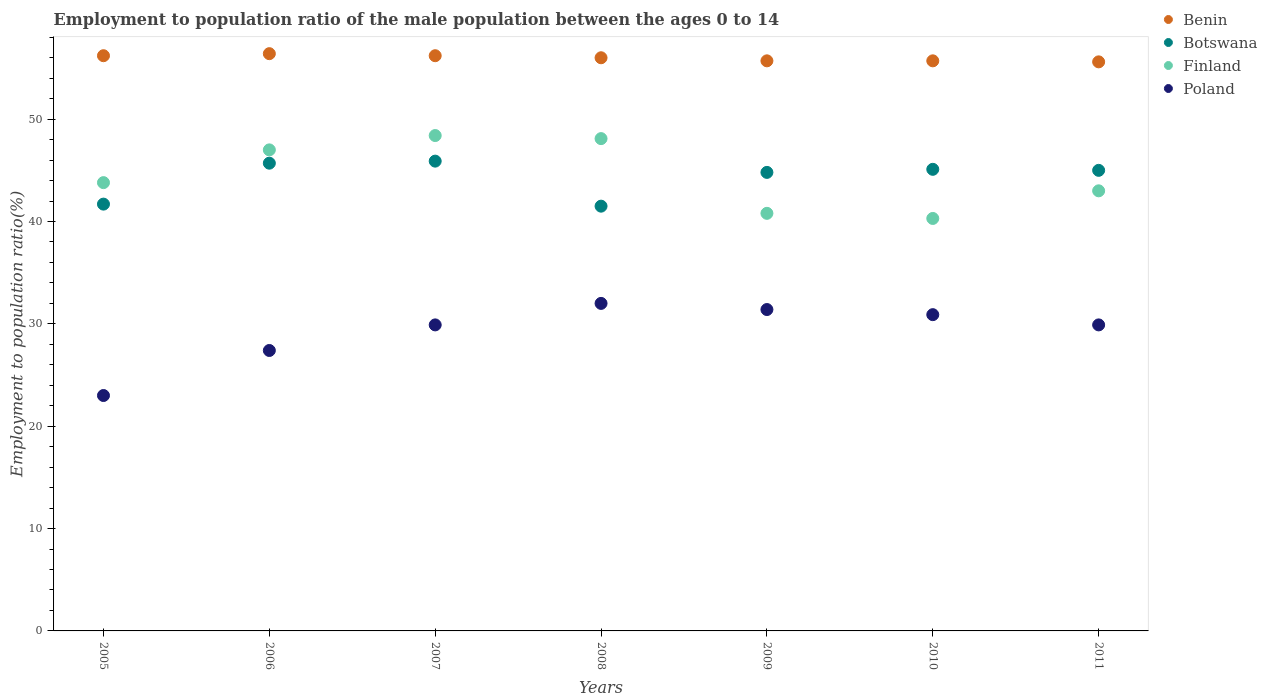How many different coloured dotlines are there?
Keep it short and to the point. 4. Is the number of dotlines equal to the number of legend labels?
Ensure brevity in your answer.  Yes. What is the employment to population ratio in Benin in 2010?
Your response must be concise. 55.7. Across all years, what is the maximum employment to population ratio in Botswana?
Offer a very short reply. 45.9. Across all years, what is the minimum employment to population ratio in Benin?
Provide a short and direct response. 55.6. In which year was the employment to population ratio in Poland minimum?
Your answer should be compact. 2005. What is the total employment to population ratio in Poland in the graph?
Your answer should be very brief. 204.5. What is the difference between the employment to population ratio in Benin in 2009 and that in 2011?
Your answer should be very brief. 0.1. What is the difference between the employment to population ratio in Finland in 2011 and the employment to population ratio in Poland in 2007?
Your answer should be very brief. 13.1. What is the average employment to population ratio in Benin per year?
Offer a terse response. 55.97. In the year 2007, what is the difference between the employment to population ratio in Finland and employment to population ratio in Benin?
Provide a short and direct response. -7.8. What is the ratio of the employment to population ratio in Finland in 2005 to that in 2010?
Provide a short and direct response. 1.09. What is the difference between the highest and the second highest employment to population ratio in Poland?
Ensure brevity in your answer.  0.6. What is the difference between the highest and the lowest employment to population ratio in Botswana?
Give a very brief answer. 4.4. Is the sum of the employment to population ratio in Benin in 2006 and 2008 greater than the maximum employment to population ratio in Poland across all years?
Your answer should be very brief. Yes. Is it the case that in every year, the sum of the employment to population ratio in Benin and employment to population ratio in Botswana  is greater than the employment to population ratio in Poland?
Keep it short and to the point. Yes. Does the employment to population ratio in Poland monotonically increase over the years?
Your answer should be compact. No. How many dotlines are there?
Your response must be concise. 4. What is the difference between two consecutive major ticks on the Y-axis?
Offer a very short reply. 10. Does the graph contain grids?
Provide a succinct answer. No. What is the title of the graph?
Your answer should be very brief. Employment to population ratio of the male population between the ages 0 to 14. What is the Employment to population ratio(%) of Benin in 2005?
Your answer should be very brief. 56.2. What is the Employment to population ratio(%) in Botswana in 2005?
Your answer should be very brief. 41.7. What is the Employment to population ratio(%) in Finland in 2005?
Keep it short and to the point. 43.8. What is the Employment to population ratio(%) in Benin in 2006?
Provide a short and direct response. 56.4. What is the Employment to population ratio(%) in Botswana in 2006?
Your answer should be very brief. 45.7. What is the Employment to population ratio(%) in Poland in 2006?
Your answer should be compact. 27.4. What is the Employment to population ratio(%) in Benin in 2007?
Provide a succinct answer. 56.2. What is the Employment to population ratio(%) in Botswana in 2007?
Give a very brief answer. 45.9. What is the Employment to population ratio(%) in Finland in 2007?
Provide a succinct answer. 48.4. What is the Employment to population ratio(%) in Poland in 2007?
Your response must be concise. 29.9. What is the Employment to population ratio(%) of Benin in 2008?
Your answer should be compact. 56. What is the Employment to population ratio(%) of Botswana in 2008?
Your response must be concise. 41.5. What is the Employment to population ratio(%) of Finland in 2008?
Provide a succinct answer. 48.1. What is the Employment to population ratio(%) of Benin in 2009?
Provide a short and direct response. 55.7. What is the Employment to population ratio(%) in Botswana in 2009?
Offer a very short reply. 44.8. What is the Employment to population ratio(%) in Finland in 2009?
Offer a very short reply. 40.8. What is the Employment to population ratio(%) of Poland in 2009?
Your answer should be very brief. 31.4. What is the Employment to population ratio(%) of Benin in 2010?
Offer a very short reply. 55.7. What is the Employment to population ratio(%) in Botswana in 2010?
Provide a succinct answer. 45.1. What is the Employment to population ratio(%) in Finland in 2010?
Offer a terse response. 40.3. What is the Employment to population ratio(%) of Poland in 2010?
Provide a short and direct response. 30.9. What is the Employment to population ratio(%) of Benin in 2011?
Ensure brevity in your answer.  55.6. What is the Employment to population ratio(%) in Botswana in 2011?
Offer a very short reply. 45. What is the Employment to population ratio(%) in Poland in 2011?
Offer a very short reply. 29.9. Across all years, what is the maximum Employment to population ratio(%) in Benin?
Ensure brevity in your answer.  56.4. Across all years, what is the maximum Employment to population ratio(%) of Botswana?
Your response must be concise. 45.9. Across all years, what is the maximum Employment to population ratio(%) of Finland?
Offer a terse response. 48.4. Across all years, what is the minimum Employment to population ratio(%) in Benin?
Keep it short and to the point. 55.6. Across all years, what is the minimum Employment to population ratio(%) in Botswana?
Keep it short and to the point. 41.5. Across all years, what is the minimum Employment to population ratio(%) in Finland?
Your answer should be very brief. 40.3. What is the total Employment to population ratio(%) in Benin in the graph?
Offer a terse response. 391.8. What is the total Employment to population ratio(%) of Botswana in the graph?
Your answer should be compact. 309.7. What is the total Employment to population ratio(%) of Finland in the graph?
Ensure brevity in your answer.  311.4. What is the total Employment to population ratio(%) of Poland in the graph?
Your answer should be very brief. 204.5. What is the difference between the Employment to population ratio(%) in Benin in 2005 and that in 2006?
Ensure brevity in your answer.  -0.2. What is the difference between the Employment to population ratio(%) in Botswana in 2005 and that in 2006?
Keep it short and to the point. -4. What is the difference between the Employment to population ratio(%) of Finland in 2005 and that in 2006?
Make the answer very short. -3.2. What is the difference between the Employment to population ratio(%) in Finland in 2005 and that in 2007?
Ensure brevity in your answer.  -4.6. What is the difference between the Employment to population ratio(%) of Poland in 2005 and that in 2007?
Make the answer very short. -6.9. What is the difference between the Employment to population ratio(%) of Benin in 2005 and that in 2008?
Offer a very short reply. 0.2. What is the difference between the Employment to population ratio(%) in Finland in 2005 and that in 2008?
Offer a very short reply. -4.3. What is the difference between the Employment to population ratio(%) in Poland in 2005 and that in 2008?
Offer a terse response. -9. What is the difference between the Employment to population ratio(%) of Finland in 2005 and that in 2009?
Make the answer very short. 3. What is the difference between the Employment to population ratio(%) in Benin in 2005 and that in 2010?
Your answer should be very brief. 0.5. What is the difference between the Employment to population ratio(%) of Finland in 2005 and that in 2010?
Provide a succinct answer. 3.5. What is the difference between the Employment to population ratio(%) in Poland in 2005 and that in 2010?
Offer a very short reply. -7.9. What is the difference between the Employment to population ratio(%) in Finland in 2005 and that in 2011?
Give a very brief answer. 0.8. What is the difference between the Employment to population ratio(%) in Poland in 2005 and that in 2011?
Your answer should be very brief. -6.9. What is the difference between the Employment to population ratio(%) of Benin in 2006 and that in 2007?
Give a very brief answer. 0.2. What is the difference between the Employment to population ratio(%) of Botswana in 2006 and that in 2007?
Keep it short and to the point. -0.2. What is the difference between the Employment to population ratio(%) in Benin in 2006 and that in 2008?
Make the answer very short. 0.4. What is the difference between the Employment to population ratio(%) of Poland in 2006 and that in 2008?
Offer a very short reply. -4.6. What is the difference between the Employment to population ratio(%) in Benin in 2006 and that in 2009?
Keep it short and to the point. 0.7. What is the difference between the Employment to population ratio(%) of Botswana in 2006 and that in 2010?
Offer a very short reply. 0.6. What is the difference between the Employment to population ratio(%) in Finland in 2006 and that in 2010?
Your answer should be very brief. 6.7. What is the difference between the Employment to population ratio(%) in Poland in 2006 and that in 2010?
Give a very brief answer. -3.5. What is the difference between the Employment to population ratio(%) in Benin in 2006 and that in 2011?
Ensure brevity in your answer.  0.8. What is the difference between the Employment to population ratio(%) of Poland in 2006 and that in 2011?
Offer a very short reply. -2.5. What is the difference between the Employment to population ratio(%) in Benin in 2007 and that in 2008?
Ensure brevity in your answer.  0.2. What is the difference between the Employment to population ratio(%) of Botswana in 2007 and that in 2008?
Provide a succinct answer. 4.4. What is the difference between the Employment to population ratio(%) of Finland in 2007 and that in 2008?
Provide a short and direct response. 0.3. What is the difference between the Employment to population ratio(%) in Finland in 2007 and that in 2009?
Your answer should be compact. 7.6. What is the difference between the Employment to population ratio(%) in Poland in 2007 and that in 2009?
Provide a short and direct response. -1.5. What is the difference between the Employment to population ratio(%) of Benin in 2007 and that in 2010?
Ensure brevity in your answer.  0.5. What is the difference between the Employment to population ratio(%) in Finland in 2007 and that in 2010?
Ensure brevity in your answer.  8.1. What is the difference between the Employment to population ratio(%) in Botswana in 2007 and that in 2011?
Give a very brief answer. 0.9. What is the difference between the Employment to population ratio(%) of Poland in 2007 and that in 2011?
Your response must be concise. 0. What is the difference between the Employment to population ratio(%) in Finland in 2008 and that in 2009?
Your answer should be compact. 7.3. What is the difference between the Employment to population ratio(%) of Poland in 2008 and that in 2009?
Your response must be concise. 0.6. What is the difference between the Employment to population ratio(%) of Finland in 2008 and that in 2010?
Give a very brief answer. 7.8. What is the difference between the Employment to population ratio(%) in Poland in 2008 and that in 2011?
Your answer should be very brief. 2.1. What is the difference between the Employment to population ratio(%) of Benin in 2009 and that in 2010?
Keep it short and to the point. 0. What is the difference between the Employment to population ratio(%) of Botswana in 2009 and that in 2010?
Ensure brevity in your answer.  -0.3. What is the difference between the Employment to population ratio(%) in Poland in 2009 and that in 2010?
Offer a terse response. 0.5. What is the difference between the Employment to population ratio(%) of Benin in 2009 and that in 2011?
Offer a very short reply. 0.1. What is the difference between the Employment to population ratio(%) in Botswana in 2009 and that in 2011?
Your answer should be very brief. -0.2. What is the difference between the Employment to population ratio(%) in Poland in 2009 and that in 2011?
Keep it short and to the point. 1.5. What is the difference between the Employment to population ratio(%) in Benin in 2010 and that in 2011?
Your response must be concise. 0.1. What is the difference between the Employment to population ratio(%) in Botswana in 2010 and that in 2011?
Provide a succinct answer. 0.1. What is the difference between the Employment to population ratio(%) of Benin in 2005 and the Employment to population ratio(%) of Poland in 2006?
Your answer should be very brief. 28.8. What is the difference between the Employment to population ratio(%) of Benin in 2005 and the Employment to population ratio(%) of Poland in 2007?
Provide a succinct answer. 26.3. What is the difference between the Employment to population ratio(%) of Botswana in 2005 and the Employment to population ratio(%) of Finland in 2007?
Your answer should be very brief. -6.7. What is the difference between the Employment to population ratio(%) of Botswana in 2005 and the Employment to population ratio(%) of Poland in 2007?
Provide a succinct answer. 11.8. What is the difference between the Employment to population ratio(%) of Finland in 2005 and the Employment to population ratio(%) of Poland in 2007?
Make the answer very short. 13.9. What is the difference between the Employment to population ratio(%) of Benin in 2005 and the Employment to population ratio(%) of Botswana in 2008?
Offer a very short reply. 14.7. What is the difference between the Employment to population ratio(%) in Benin in 2005 and the Employment to population ratio(%) in Poland in 2008?
Provide a succinct answer. 24.2. What is the difference between the Employment to population ratio(%) of Botswana in 2005 and the Employment to population ratio(%) of Finland in 2008?
Provide a succinct answer. -6.4. What is the difference between the Employment to population ratio(%) of Benin in 2005 and the Employment to population ratio(%) of Botswana in 2009?
Make the answer very short. 11.4. What is the difference between the Employment to population ratio(%) in Benin in 2005 and the Employment to population ratio(%) in Poland in 2009?
Keep it short and to the point. 24.8. What is the difference between the Employment to population ratio(%) in Benin in 2005 and the Employment to population ratio(%) in Poland in 2010?
Your answer should be very brief. 25.3. What is the difference between the Employment to population ratio(%) of Botswana in 2005 and the Employment to population ratio(%) of Poland in 2010?
Your answer should be compact. 10.8. What is the difference between the Employment to population ratio(%) of Finland in 2005 and the Employment to population ratio(%) of Poland in 2010?
Provide a succinct answer. 12.9. What is the difference between the Employment to population ratio(%) in Benin in 2005 and the Employment to population ratio(%) in Botswana in 2011?
Give a very brief answer. 11.2. What is the difference between the Employment to population ratio(%) in Benin in 2005 and the Employment to population ratio(%) in Finland in 2011?
Make the answer very short. 13.2. What is the difference between the Employment to population ratio(%) in Benin in 2005 and the Employment to population ratio(%) in Poland in 2011?
Provide a succinct answer. 26.3. What is the difference between the Employment to population ratio(%) of Finland in 2005 and the Employment to population ratio(%) of Poland in 2011?
Give a very brief answer. 13.9. What is the difference between the Employment to population ratio(%) in Benin in 2006 and the Employment to population ratio(%) in Botswana in 2007?
Give a very brief answer. 10.5. What is the difference between the Employment to population ratio(%) in Benin in 2006 and the Employment to population ratio(%) in Finland in 2007?
Offer a terse response. 8. What is the difference between the Employment to population ratio(%) of Benin in 2006 and the Employment to population ratio(%) of Poland in 2007?
Make the answer very short. 26.5. What is the difference between the Employment to population ratio(%) of Botswana in 2006 and the Employment to population ratio(%) of Finland in 2007?
Provide a succinct answer. -2.7. What is the difference between the Employment to population ratio(%) in Benin in 2006 and the Employment to population ratio(%) in Finland in 2008?
Keep it short and to the point. 8.3. What is the difference between the Employment to population ratio(%) of Benin in 2006 and the Employment to population ratio(%) of Poland in 2008?
Give a very brief answer. 24.4. What is the difference between the Employment to population ratio(%) in Botswana in 2006 and the Employment to population ratio(%) in Finland in 2008?
Give a very brief answer. -2.4. What is the difference between the Employment to population ratio(%) of Botswana in 2006 and the Employment to population ratio(%) of Poland in 2008?
Make the answer very short. 13.7. What is the difference between the Employment to population ratio(%) in Finland in 2006 and the Employment to population ratio(%) in Poland in 2008?
Offer a very short reply. 15. What is the difference between the Employment to population ratio(%) of Benin in 2006 and the Employment to population ratio(%) of Poland in 2009?
Your answer should be compact. 25. What is the difference between the Employment to population ratio(%) of Botswana in 2006 and the Employment to population ratio(%) of Finland in 2009?
Provide a succinct answer. 4.9. What is the difference between the Employment to population ratio(%) of Botswana in 2006 and the Employment to population ratio(%) of Finland in 2010?
Provide a short and direct response. 5.4. What is the difference between the Employment to population ratio(%) in Botswana in 2006 and the Employment to population ratio(%) in Poland in 2010?
Your response must be concise. 14.8. What is the difference between the Employment to population ratio(%) of Benin in 2006 and the Employment to population ratio(%) of Botswana in 2011?
Ensure brevity in your answer.  11.4. What is the difference between the Employment to population ratio(%) of Benin in 2006 and the Employment to population ratio(%) of Poland in 2011?
Offer a terse response. 26.5. What is the difference between the Employment to population ratio(%) of Botswana in 2006 and the Employment to population ratio(%) of Finland in 2011?
Your answer should be very brief. 2.7. What is the difference between the Employment to population ratio(%) of Finland in 2006 and the Employment to population ratio(%) of Poland in 2011?
Your answer should be compact. 17.1. What is the difference between the Employment to population ratio(%) in Benin in 2007 and the Employment to population ratio(%) in Botswana in 2008?
Offer a terse response. 14.7. What is the difference between the Employment to population ratio(%) in Benin in 2007 and the Employment to population ratio(%) in Finland in 2008?
Your answer should be compact. 8.1. What is the difference between the Employment to population ratio(%) in Benin in 2007 and the Employment to population ratio(%) in Poland in 2008?
Keep it short and to the point. 24.2. What is the difference between the Employment to population ratio(%) in Botswana in 2007 and the Employment to population ratio(%) in Finland in 2008?
Make the answer very short. -2.2. What is the difference between the Employment to population ratio(%) of Benin in 2007 and the Employment to population ratio(%) of Botswana in 2009?
Offer a terse response. 11.4. What is the difference between the Employment to population ratio(%) of Benin in 2007 and the Employment to population ratio(%) of Finland in 2009?
Give a very brief answer. 15.4. What is the difference between the Employment to population ratio(%) in Benin in 2007 and the Employment to population ratio(%) in Poland in 2009?
Ensure brevity in your answer.  24.8. What is the difference between the Employment to population ratio(%) of Botswana in 2007 and the Employment to population ratio(%) of Poland in 2009?
Your answer should be compact. 14.5. What is the difference between the Employment to population ratio(%) of Finland in 2007 and the Employment to population ratio(%) of Poland in 2009?
Ensure brevity in your answer.  17. What is the difference between the Employment to population ratio(%) of Benin in 2007 and the Employment to population ratio(%) of Botswana in 2010?
Give a very brief answer. 11.1. What is the difference between the Employment to population ratio(%) of Benin in 2007 and the Employment to population ratio(%) of Finland in 2010?
Give a very brief answer. 15.9. What is the difference between the Employment to population ratio(%) of Benin in 2007 and the Employment to population ratio(%) of Poland in 2010?
Make the answer very short. 25.3. What is the difference between the Employment to population ratio(%) of Botswana in 2007 and the Employment to population ratio(%) of Finland in 2010?
Offer a very short reply. 5.6. What is the difference between the Employment to population ratio(%) of Botswana in 2007 and the Employment to population ratio(%) of Poland in 2010?
Give a very brief answer. 15. What is the difference between the Employment to population ratio(%) of Benin in 2007 and the Employment to population ratio(%) of Botswana in 2011?
Your answer should be compact. 11.2. What is the difference between the Employment to population ratio(%) in Benin in 2007 and the Employment to population ratio(%) in Finland in 2011?
Give a very brief answer. 13.2. What is the difference between the Employment to population ratio(%) in Benin in 2007 and the Employment to population ratio(%) in Poland in 2011?
Offer a terse response. 26.3. What is the difference between the Employment to population ratio(%) in Botswana in 2007 and the Employment to population ratio(%) in Finland in 2011?
Keep it short and to the point. 2.9. What is the difference between the Employment to population ratio(%) of Benin in 2008 and the Employment to population ratio(%) of Botswana in 2009?
Your answer should be very brief. 11.2. What is the difference between the Employment to population ratio(%) of Benin in 2008 and the Employment to population ratio(%) of Finland in 2009?
Ensure brevity in your answer.  15.2. What is the difference between the Employment to population ratio(%) in Benin in 2008 and the Employment to population ratio(%) in Poland in 2009?
Your answer should be compact. 24.6. What is the difference between the Employment to population ratio(%) of Botswana in 2008 and the Employment to population ratio(%) of Finland in 2009?
Offer a very short reply. 0.7. What is the difference between the Employment to population ratio(%) in Benin in 2008 and the Employment to population ratio(%) in Poland in 2010?
Your answer should be compact. 25.1. What is the difference between the Employment to population ratio(%) of Botswana in 2008 and the Employment to population ratio(%) of Finland in 2010?
Offer a terse response. 1.2. What is the difference between the Employment to population ratio(%) in Finland in 2008 and the Employment to population ratio(%) in Poland in 2010?
Make the answer very short. 17.2. What is the difference between the Employment to population ratio(%) of Benin in 2008 and the Employment to population ratio(%) of Botswana in 2011?
Ensure brevity in your answer.  11. What is the difference between the Employment to population ratio(%) of Benin in 2008 and the Employment to population ratio(%) of Finland in 2011?
Keep it short and to the point. 13. What is the difference between the Employment to population ratio(%) of Benin in 2008 and the Employment to population ratio(%) of Poland in 2011?
Keep it short and to the point. 26.1. What is the difference between the Employment to population ratio(%) of Botswana in 2008 and the Employment to population ratio(%) of Finland in 2011?
Keep it short and to the point. -1.5. What is the difference between the Employment to population ratio(%) in Benin in 2009 and the Employment to population ratio(%) in Botswana in 2010?
Your response must be concise. 10.6. What is the difference between the Employment to population ratio(%) of Benin in 2009 and the Employment to population ratio(%) of Finland in 2010?
Offer a very short reply. 15.4. What is the difference between the Employment to population ratio(%) in Benin in 2009 and the Employment to population ratio(%) in Poland in 2010?
Make the answer very short. 24.8. What is the difference between the Employment to population ratio(%) in Botswana in 2009 and the Employment to population ratio(%) in Finland in 2010?
Offer a terse response. 4.5. What is the difference between the Employment to population ratio(%) of Benin in 2009 and the Employment to population ratio(%) of Botswana in 2011?
Offer a very short reply. 10.7. What is the difference between the Employment to population ratio(%) of Benin in 2009 and the Employment to population ratio(%) of Poland in 2011?
Ensure brevity in your answer.  25.8. What is the difference between the Employment to population ratio(%) of Botswana in 2009 and the Employment to population ratio(%) of Poland in 2011?
Provide a short and direct response. 14.9. What is the difference between the Employment to population ratio(%) of Finland in 2009 and the Employment to population ratio(%) of Poland in 2011?
Keep it short and to the point. 10.9. What is the difference between the Employment to population ratio(%) of Benin in 2010 and the Employment to population ratio(%) of Botswana in 2011?
Keep it short and to the point. 10.7. What is the difference between the Employment to population ratio(%) of Benin in 2010 and the Employment to population ratio(%) of Poland in 2011?
Your answer should be very brief. 25.8. What is the difference between the Employment to population ratio(%) in Botswana in 2010 and the Employment to population ratio(%) in Poland in 2011?
Provide a succinct answer. 15.2. What is the average Employment to population ratio(%) in Benin per year?
Offer a very short reply. 55.97. What is the average Employment to population ratio(%) in Botswana per year?
Provide a succinct answer. 44.24. What is the average Employment to population ratio(%) of Finland per year?
Provide a short and direct response. 44.49. What is the average Employment to population ratio(%) in Poland per year?
Offer a terse response. 29.21. In the year 2005, what is the difference between the Employment to population ratio(%) in Benin and Employment to population ratio(%) in Finland?
Offer a very short reply. 12.4. In the year 2005, what is the difference between the Employment to population ratio(%) of Benin and Employment to population ratio(%) of Poland?
Keep it short and to the point. 33.2. In the year 2005, what is the difference between the Employment to population ratio(%) of Finland and Employment to population ratio(%) of Poland?
Your response must be concise. 20.8. In the year 2006, what is the difference between the Employment to population ratio(%) in Benin and Employment to population ratio(%) in Botswana?
Your answer should be compact. 10.7. In the year 2006, what is the difference between the Employment to population ratio(%) of Benin and Employment to population ratio(%) of Finland?
Your response must be concise. 9.4. In the year 2006, what is the difference between the Employment to population ratio(%) of Botswana and Employment to population ratio(%) of Poland?
Provide a short and direct response. 18.3. In the year 2006, what is the difference between the Employment to population ratio(%) in Finland and Employment to population ratio(%) in Poland?
Make the answer very short. 19.6. In the year 2007, what is the difference between the Employment to population ratio(%) of Benin and Employment to population ratio(%) of Finland?
Give a very brief answer. 7.8. In the year 2007, what is the difference between the Employment to population ratio(%) in Benin and Employment to population ratio(%) in Poland?
Provide a succinct answer. 26.3. In the year 2007, what is the difference between the Employment to population ratio(%) of Botswana and Employment to population ratio(%) of Finland?
Ensure brevity in your answer.  -2.5. In the year 2007, what is the difference between the Employment to population ratio(%) of Botswana and Employment to population ratio(%) of Poland?
Provide a short and direct response. 16. In the year 2007, what is the difference between the Employment to population ratio(%) of Finland and Employment to population ratio(%) of Poland?
Give a very brief answer. 18.5. In the year 2008, what is the difference between the Employment to population ratio(%) in Benin and Employment to population ratio(%) in Finland?
Provide a short and direct response. 7.9. In the year 2008, what is the difference between the Employment to population ratio(%) of Botswana and Employment to population ratio(%) of Finland?
Keep it short and to the point. -6.6. In the year 2008, what is the difference between the Employment to population ratio(%) of Botswana and Employment to population ratio(%) of Poland?
Provide a short and direct response. 9.5. In the year 2009, what is the difference between the Employment to population ratio(%) in Benin and Employment to population ratio(%) in Botswana?
Offer a very short reply. 10.9. In the year 2009, what is the difference between the Employment to population ratio(%) in Benin and Employment to population ratio(%) in Poland?
Offer a terse response. 24.3. In the year 2009, what is the difference between the Employment to population ratio(%) of Botswana and Employment to population ratio(%) of Poland?
Give a very brief answer. 13.4. In the year 2009, what is the difference between the Employment to population ratio(%) in Finland and Employment to population ratio(%) in Poland?
Keep it short and to the point. 9.4. In the year 2010, what is the difference between the Employment to population ratio(%) in Benin and Employment to population ratio(%) in Finland?
Keep it short and to the point. 15.4. In the year 2010, what is the difference between the Employment to population ratio(%) in Benin and Employment to population ratio(%) in Poland?
Make the answer very short. 24.8. In the year 2010, what is the difference between the Employment to population ratio(%) of Botswana and Employment to population ratio(%) of Finland?
Ensure brevity in your answer.  4.8. In the year 2010, what is the difference between the Employment to population ratio(%) in Botswana and Employment to population ratio(%) in Poland?
Your answer should be very brief. 14.2. In the year 2010, what is the difference between the Employment to population ratio(%) of Finland and Employment to population ratio(%) of Poland?
Give a very brief answer. 9.4. In the year 2011, what is the difference between the Employment to population ratio(%) of Benin and Employment to population ratio(%) of Poland?
Offer a very short reply. 25.7. In the year 2011, what is the difference between the Employment to population ratio(%) in Botswana and Employment to population ratio(%) in Finland?
Offer a terse response. 2. In the year 2011, what is the difference between the Employment to population ratio(%) in Botswana and Employment to population ratio(%) in Poland?
Provide a short and direct response. 15.1. What is the ratio of the Employment to population ratio(%) of Benin in 2005 to that in 2006?
Offer a very short reply. 1. What is the ratio of the Employment to population ratio(%) in Botswana in 2005 to that in 2006?
Your response must be concise. 0.91. What is the ratio of the Employment to population ratio(%) of Finland in 2005 to that in 2006?
Ensure brevity in your answer.  0.93. What is the ratio of the Employment to population ratio(%) of Poland in 2005 to that in 2006?
Keep it short and to the point. 0.84. What is the ratio of the Employment to population ratio(%) in Benin in 2005 to that in 2007?
Provide a succinct answer. 1. What is the ratio of the Employment to population ratio(%) in Botswana in 2005 to that in 2007?
Provide a succinct answer. 0.91. What is the ratio of the Employment to population ratio(%) of Finland in 2005 to that in 2007?
Your answer should be compact. 0.91. What is the ratio of the Employment to population ratio(%) in Poland in 2005 to that in 2007?
Your answer should be compact. 0.77. What is the ratio of the Employment to population ratio(%) in Benin in 2005 to that in 2008?
Provide a succinct answer. 1. What is the ratio of the Employment to population ratio(%) of Botswana in 2005 to that in 2008?
Your response must be concise. 1. What is the ratio of the Employment to population ratio(%) in Finland in 2005 to that in 2008?
Provide a succinct answer. 0.91. What is the ratio of the Employment to population ratio(%) of Poland in 2005 to that in 2008?
Your answer should be very brief. 0.72. What is the ratio of the Employment to population ratio(%) of Benin in 2005 to that in 2009?
Keep it short and to the point. 1.01. What is the ratio of the Employment to population ratio(%) of Botswana in 2005 to that in 2009?
Ensure brevity in your answer.  0.93. What is the ratio of the Employment to population ratio(%) of Finland in 2005 to that in 2009?
Your answer should be very brief. 1.07. What is the ratio of the Employment to population ratio(%) in Poland in 2005 to that in 2009?
Make the answer very short. 0.73. What is the ratio of the Employment to population ratio(%) in Benin in 2005 to that in 2010?
Give a very brief answer. 1.01. What is the ratio of the Employment to population ratio(%) of Botswana in 2005 to that in 2010?
Provide a short and direct response. 0.92. What is the ratio of the Employment to population ratio(%) in Finland in 2005 to that in 2010?
Provide a short and direct response. 1.09. What is the ratio of the Employment to population ratio(%) in Poland in 2005 to that in 2010?
Make the answer very short. 0.74. What is the ratio of the Employment to population ratio(%) of Benin in 2005 to that in 2011?
Provide a succinct answer. 1.01. What is the ratio of the Employment to population ratio(%) in Botswana in 2005 to that in 2011?
Your answer should be compact. 0.93. What is the ratio of the Employment to population ratio(%) of Finland in 2005 to that in 2011?
Keep it short and to the point. 1.02. What is the ratio of the Employment to population ratio(%) in Poland in 2005 to that in 2011?
Offer a terse response. 0.77. What is the ratio of the Employment to population ratio(%) in Botswana in 2006 to that in 2007?
Keep it short and to the point. 1. What is the ratio of the Employment to population ratio(%) of Finland in 2006 to that in 2007?
Ensure brevity in your answer.  0.97. What is the ratio of the Employment to population ratio(%) of Poland in 2006 to that in 2007?
Keep it short and to the point. 0.92. What is the ratio of the Employment to population ratio(%) in Benin in 2006 to that in 2008?
Your response must be concise. 1.01. What is the ratio of the Employment to population ratio(%) in Botswana in 2006 to that in 2008?
Your response must be concise. 1.1. What is the ratio of the Employment to population ratio(%) in Finland in 2006 to that in 2008?
Keep it short and to the point. 0.98. What is the ratio of the Employment to population ratio(%) of Poland in 2006 to that in 2008?
Offer a very short reply. 0.86. What is the ratio of the Employment to population ratio(%) of Benin in 2006 to that in 2009?
Make the answer very short. 1.01. What is the ratio of the Employment to population ratio(%) in Botswana in 2006 to that in 2009?
Your answer should be compact. 1.02. What is the ratio of the Employment to population ratio(%) in Finland in 2006 to that in 2009?
Your answer should be compact. 1.15. What is the ratio of the Employment to population ratio(%) of Poland in 2006 to that in 2009?
Provide a short and direct response. 0.87. What is the ratio of the Employment to population ratio(%) in Benin in 2006 to that in 2010?
Provide a short and direct response. 1.01. What is the ratio of the Employment to population ratio(%) of Botswana in 2006 to that in 2010?
Make the answer very short. 1.01. What is the ratio of the Employment to population ratio(%) of Finland in 2006 to that in 2010?
Your response must be concise. 1.17. What is the ratio of the Employment to population ratio(%) in Poland in 2006 to that in 2010?
Your response must be concise. 0.89. What is the ratio of the Employment to population ratio(%) of Benin in 2006 to that in 2011?
Offer a terse response. 1.01. What is the ratio of the Employment to population ratio(%) of Botswana in 2006 to that in 2011?
Ensure brevity in your answer.  1.02. What is the ratio of the Employment to population ratio(%) of Finland in 2006 to that in 2011?
Your answer should be very brief. 1.09. What is the ratio of the Employment to population ratio(%) of Poland in 2006 to that in 2011?
Provide a short and direct response. 0.92. What is the ratio of the Employment to population ratio(%) of Benin in 2007 to that in 2008?
Give a very brief answer. 1. What is the ratio of the Employment to population ratio(%) of Botswana in 2007 to that in 2008?
Provide a short and direct response. 1.11. What is the ratio of the Employment to population ratio(%) of Poland in 2007 to that in 2008?
Ensure brevity in your answer.  0.93. What is the ratio of the Employment to population ratio(%) of Benin in 2007 to that in 2009?
Ensure brevity in your answer.  1.01. What is the ratio of the Employment to population ratio(%) in Botswana in 2007 to that in 2009?
Your response must be concise. 1.02. What is the ratio of the Employment to population ratio(%) in Finland in 2007 to that in 2009?
Offer a very short reply. 1.19. What is the ratio of the Employment to population ratio(%) of Poland in 2007 to that in 2009?
Provide a succinct answer. 0.95. What is the ratio of the Employment to population ratio(%) of Benin in 2007 to that in 2010?
Your answer should be very brief. 1.01. What is the ratio of the Employment to population ratio(%) in Botswana in 2007 to that in 2010?
Give a very brief answer. 1.02. What is the ratio of the Employment to population ratio(%) of Finland in 2007 to that in 2010?
Make the answer very short. 1.2. What is the ratio of the Employment to population ratio(%) in Poland in 2007 to that in 2010?
Give a very brief answer. 0.97. What is the ratio of the Employment to population ratio(%) in Benin in 2007 to that in 2011?
Give a very brief answer. 1.01. What is the ratio of the Employment to population ratio(%) of Finland in 2007 to that in 2011?
Keep it short and to the point. 1.13. What is the ratio of the Employment to population ratio(%) of Poland in 2007 to that in 2011?
Your answer should be very brief. 1. What is the ratio of the Employment to population ratio(%) in Benin in 2008 to that in 2009?
Ensure brevity in your answer.  1.01. What is the ratio of the Employment to population ratio(%) in Botswana in 2008 to that in 2009?
Your answer should be compact. 0.93. What is the ratio of the Employment to population ratio(%) in Finland in 2008 to that in 2009?
Your answer should be very brief. 1.18. What is the ratio of the Employment to population ratio(%) in Poland in 2008 to that in 2009?
Provide a succinct answer. 1.02. What is the ratio of the Employment to population ratio(%) of Benin in 2008 to that in 2010?
Make the answer very short. 1.01. What is the ratio of the Employment to population ratio(%) in Botswana in 2008 to that in 2010?
Provide a succinct answer. 0.92. What is the ratio of the Employment to population ratio(%) of Finland in 2008 to that in 2010?
Your answer should be compact. 1.19. What is the ratio of the Employment to population ratio(%) in Poland in 2008 to that in 2010?
Provide a succinct answer. 1.04. What is the ratio of the Employment to population ratio(%) in Benin in 2008 to that in 2011?
Make the answer very short. 1.01. What is the ratio of the Employment to population ratio(%) of Botswana in 2008 to that in 2011?
Your answer should be compact. 0.92. What is the ratio of the Employment to population ratio(%) of Finland in 2008 to that in 2011?
Your answer should be compact. 1.12. What is the ratio of the Employment to population ratio(%) in Poland in 2008 to that in 2011?
Give a very brief answer. 1.07. What is the ratio of the Employment to population ratio(%) of Benin in 2009 to that in 2010?
Keep it short and to the point. 1. What is the ratio of the Employment to population ratio(%) of Finland in 2009 to that in 2010?
Offer a very short reply. 1.01. What is the ratio of the Employment to population ratio(%) in Poland in 2009 to that in 2010?
Provide a short and direct response. 1.02. What is the ratio of the Employment to population ratio(%) in Finland in 2009 to that in 2011?
Your answer should be compact. 0.95. What is the ratio of the Employment to population ratio(%) in Poland in 2009 to that in 2011?
Make the answer very short. 1.05. What is the ratio of the Employment to population ratio(%) in Finland in 2010 to that in 2011?
Give a very brief answer. 0.94. What is the ratio of the Employment to population ratio(%) of Poland in 2010 to that in 2011?
Your answer should be very brief. 1.03. What is the difference between the highest and the second highest Employment to population ratio(%) of Benin?
Make the answer very short. 0.2. What is the difference between the highest and the second highest Employment to population ratio(%) in Finland?
Make the answer very short. 0.3. What is the difference between the highest and the lowest Employment to population ratio(%) of Benin?
Your response must be concise. 0.8. 